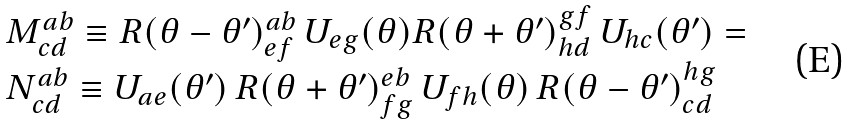Convert formula to latex. <formula><loc_0><loc_0><loc_500><loc_500>\begin{array} { l } M ^ { a b } _ { c d } \equiv R ( \theta - \theta ^ { \prime } ) ^ { a b } _ { e f } \, U _ { e g } ( \theta ) R ( \theta + \theta ^ { \prime } ) ^ { g f } _ { h d } \, U _ { h c } ( \theta ^ { \prime } ) = \\ N ^ { a b } _ { c d } \equiv U _ { a e } ( \theta ^ { \prime } ) \, R ( \theta + \theta ^ { \prime } ) ^ { e b } _ { f g } \, U _ { f h } ( \theta ) \, R ( \theta - \theta ^ { \prime } ) ^ { h g } _ { c d } \end{array}</formula> 